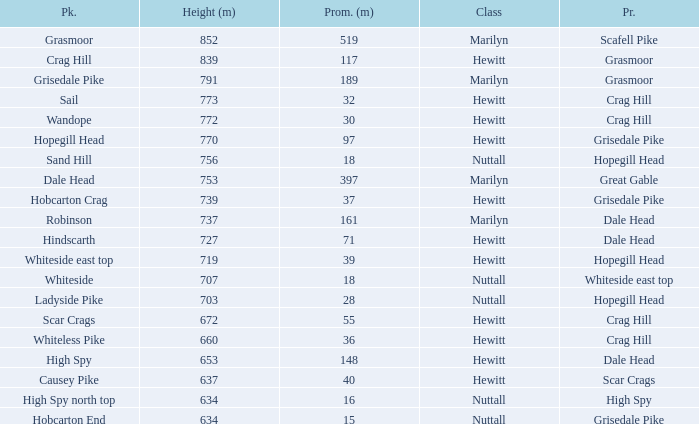What is the lowest height for Parent grasmoor when it has a Prom larger than 117? 791.0. 